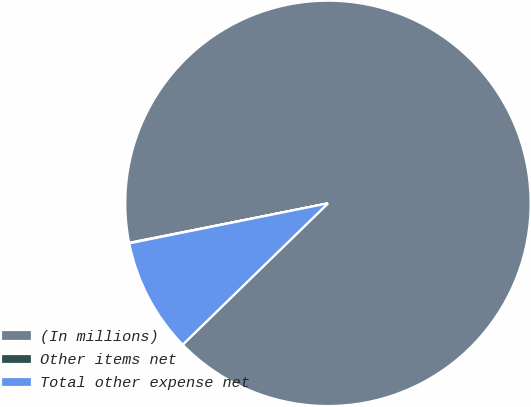Convert chart. <chart><loc_0><loc_0><loc_500><loc_500><pie_chart><fcel>(In millions)<fcel>Other items net<fcel>Total other expense net<nl><fcel>90.84%<fcel>0.04%<fcel>9.12%<nl></chart> 